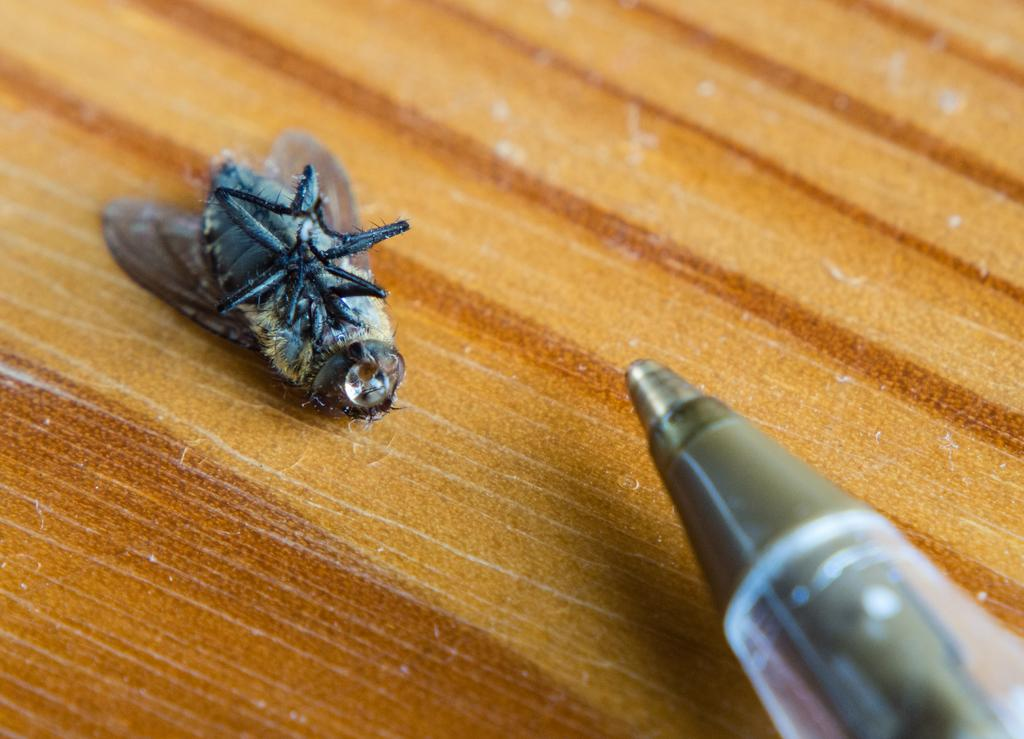What is present on the table in the image? There is a fly on the table in the image. Where can a pen be found in the image? The pen is in the bottom right corner of the image. What type of harmony is being played in the background of the image? There is no music or harmony present in the image; it only features a fly and a pen. 